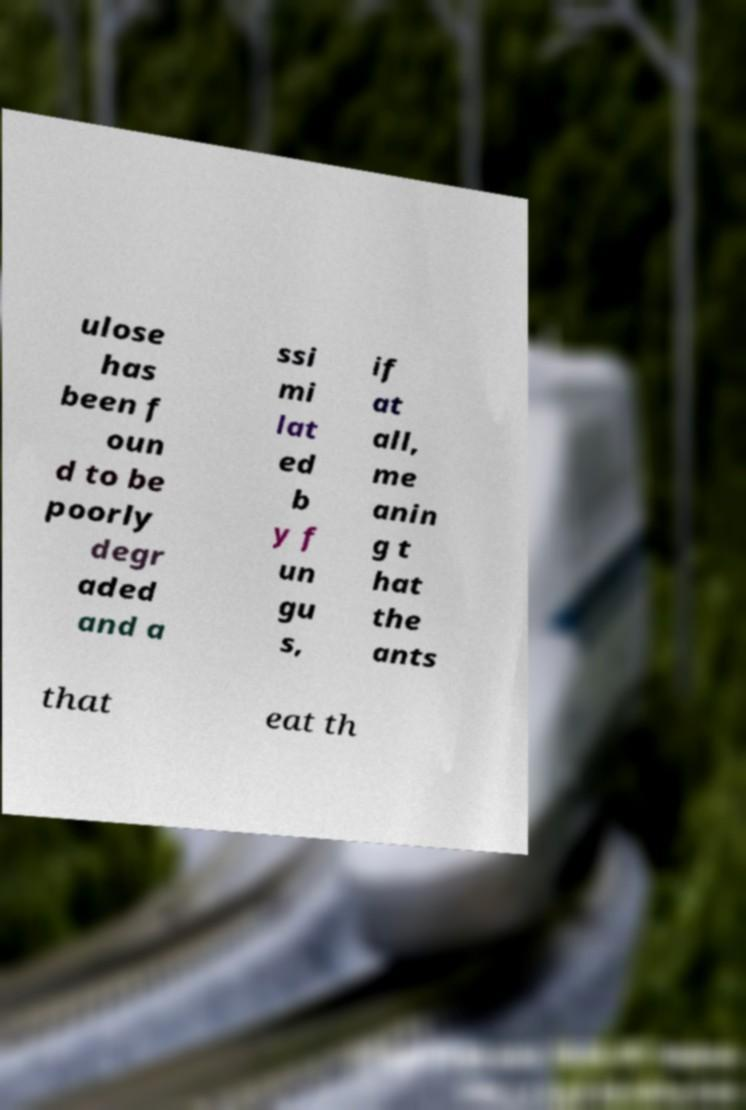Can you accurately transcribe the text from the provided image for me? ulose has been f oun d to be poorly degr aded and a ssi mi lat ed b y f un gu s, if at all, me anin g t hat the ants that eat th 